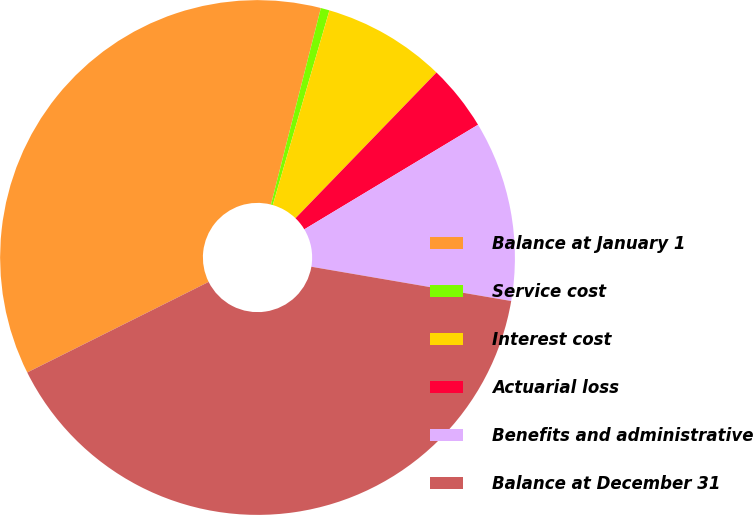Convert chart. <chart><loc_0><loc_0><loc_500><loc_500><pie_chart><fcel>Balance at January 1<fcel>Service cost<fcel>Interest cost<fcel>Actuarial loss<fcel>Benefits and administrative<fcel>Balance at December 31<nl><fcel>36.33%<fcel>0.55%<fcel>7.73%<fcel>4.14%<fcel>11.33%<fcel>39.93%<nl></chart> 